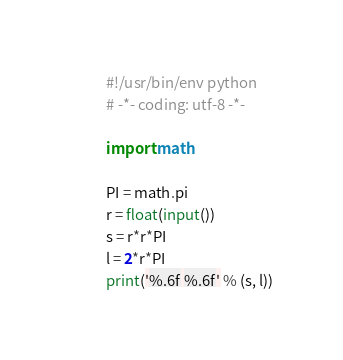Convert code to text. <code><loc_0><loc_0><loc_500><loc_500><_Python_>#!/usr/bin/env python
# -*- coding: utf-8 -*-

import math

PI = math.pi
r = float(input())
s = r*r*PI
l = 2*r*PI
print('%.6f %.6f' % (s, l))</code> 